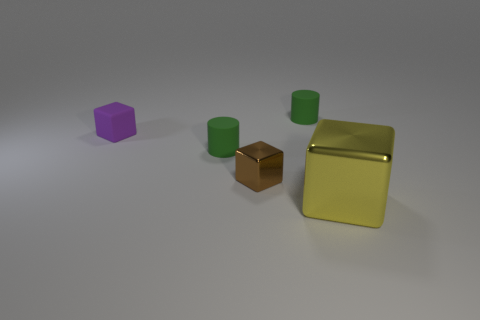How many big objects are behind the cylinder in front of the tiny object behind the purple thing?
Your answer should be very brief. 0. Is the large yellow thing the same shape as the small purple thing?
Your response must be concise. Yes. Are there any tiny metallic things of the same shape as the small purple matte thing?
Provide a short and direct response. Yes. What shape is the brown metallic object that is the same size as the purple matte cube?
Ensure brevity in your answer.  Cube. There is a small cylinder behind the small rubber thing left of the tiny green object that is in front of the tiny purple block; what is it made of?
Your response must be concise. Rubber. Is the size of the purple rubber thing the same as the brown object?
Keep it short and to the point. Yes. What is the material of the small brown cube?
Offer a very short reply. Metal. Do the small purple rubber object behind the brown metallic object and the small brown object have the same shape?
Provide a short and direct response. Yes. How many things are small rubber spheres or tiny brown metal things?
Provide a short and direct response. 1. Are the small cylinder right of the tiny brown block and the big cube made of the same material?
Offer a terse response. No. 